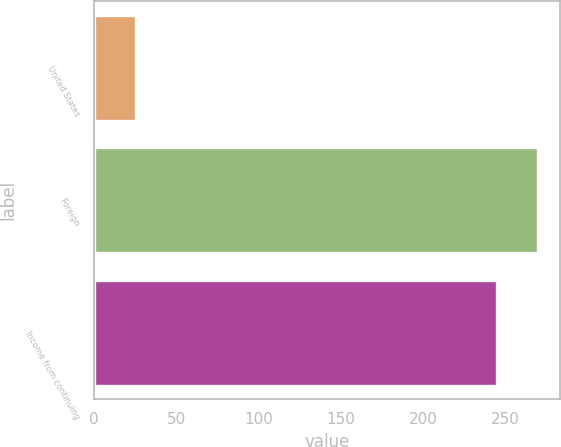<chart> <loc_0><loc_0><loc_500><loc_500><bar_chart><fcel>United States<fcel>Foreign<fcel>Income from continuing<nl><fcel>25.1<fcel>269.7<fcel>244.6<nl></chart> 